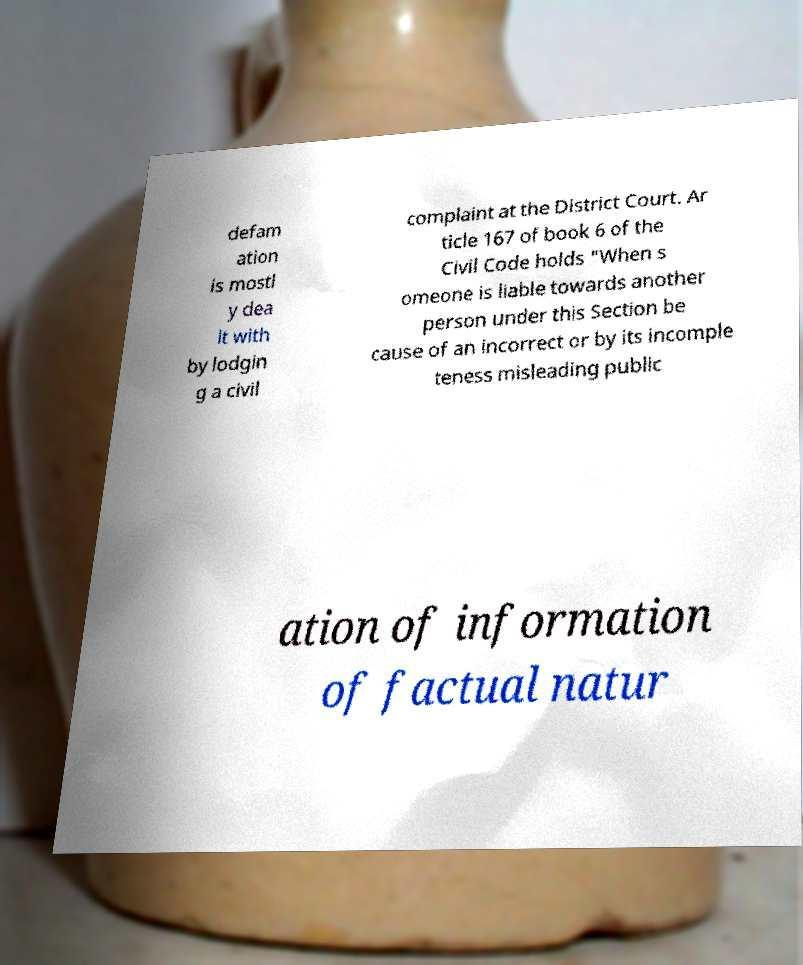I need the written content from this picture converted into text. Can you do that? defam ation is mostl y dea lt with by lodgin g a civil complaint at the District Court. Ar ticle 167 of book 6 of the Civil Code holds "When s omeone is liable towards another person under this Section be cause of an incorrect or by its incomple teness misleading public ation of information of factual natur 